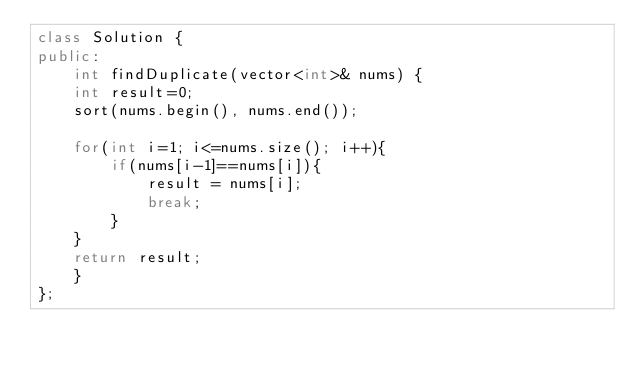<code> <loc_0><loc_0><loc_500><loc_500><_C++_>class Solution {
public:
    int findDuplicate(vector<int>& nums) {
    int result=0;
    sort(nums.begin(), nums.end());
   
    for(int i=1; i<=nums.size(); i++){
        if(nums[i-1]==nums[i]){
            result = nums[i];
            break;
        }
    }
    return result;
    }
};
</code> 